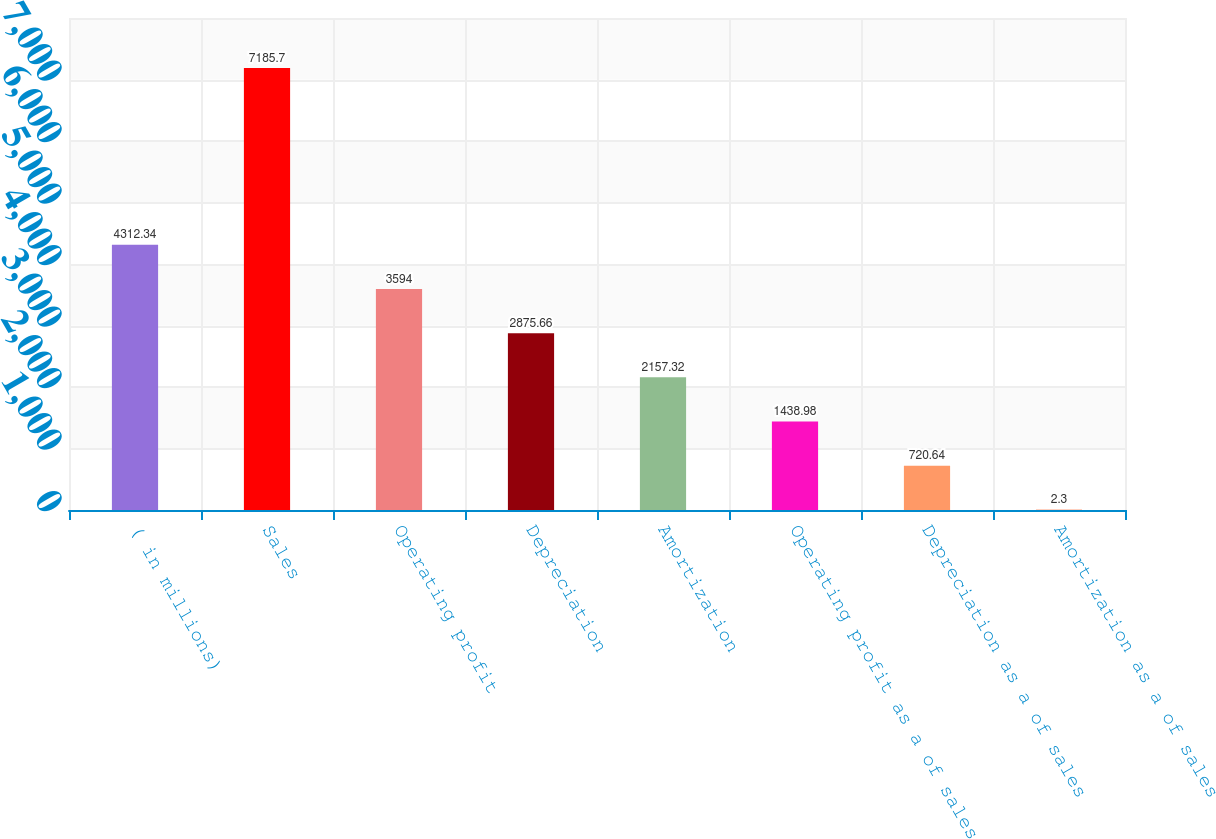Convert chart to OTSL. <chart><loc_0><loc_0><loc_500><loc_500><bar_chart><fcel>( in millions)<fcel>Sales<fcel>Operating profit<fcel>Depreciation<fcel>Amortization<fcel>Operating profit as a of sales<fcel>Depreciation as a of sales<fcel>Amortization as a of sales<nl><fcel>4312.34<fcel>7185.7<fcel>3594<fcel>2875.66<fcel>2157.32<fcel>1438.98<fcel>720.64<fcel>2.3<nl></chart> 